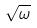Convert formula to latex. <formula><loc_0><loc_0><loc_500><loc_500>\sqrt { \omega }</formula> 